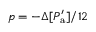Convert formula to latex. <formula><loc_0><loc_0><loc_500><loc_500>{ p = - \Delta [ P _ { a } ^ { \prime } ] / 1 2 }</formula> 